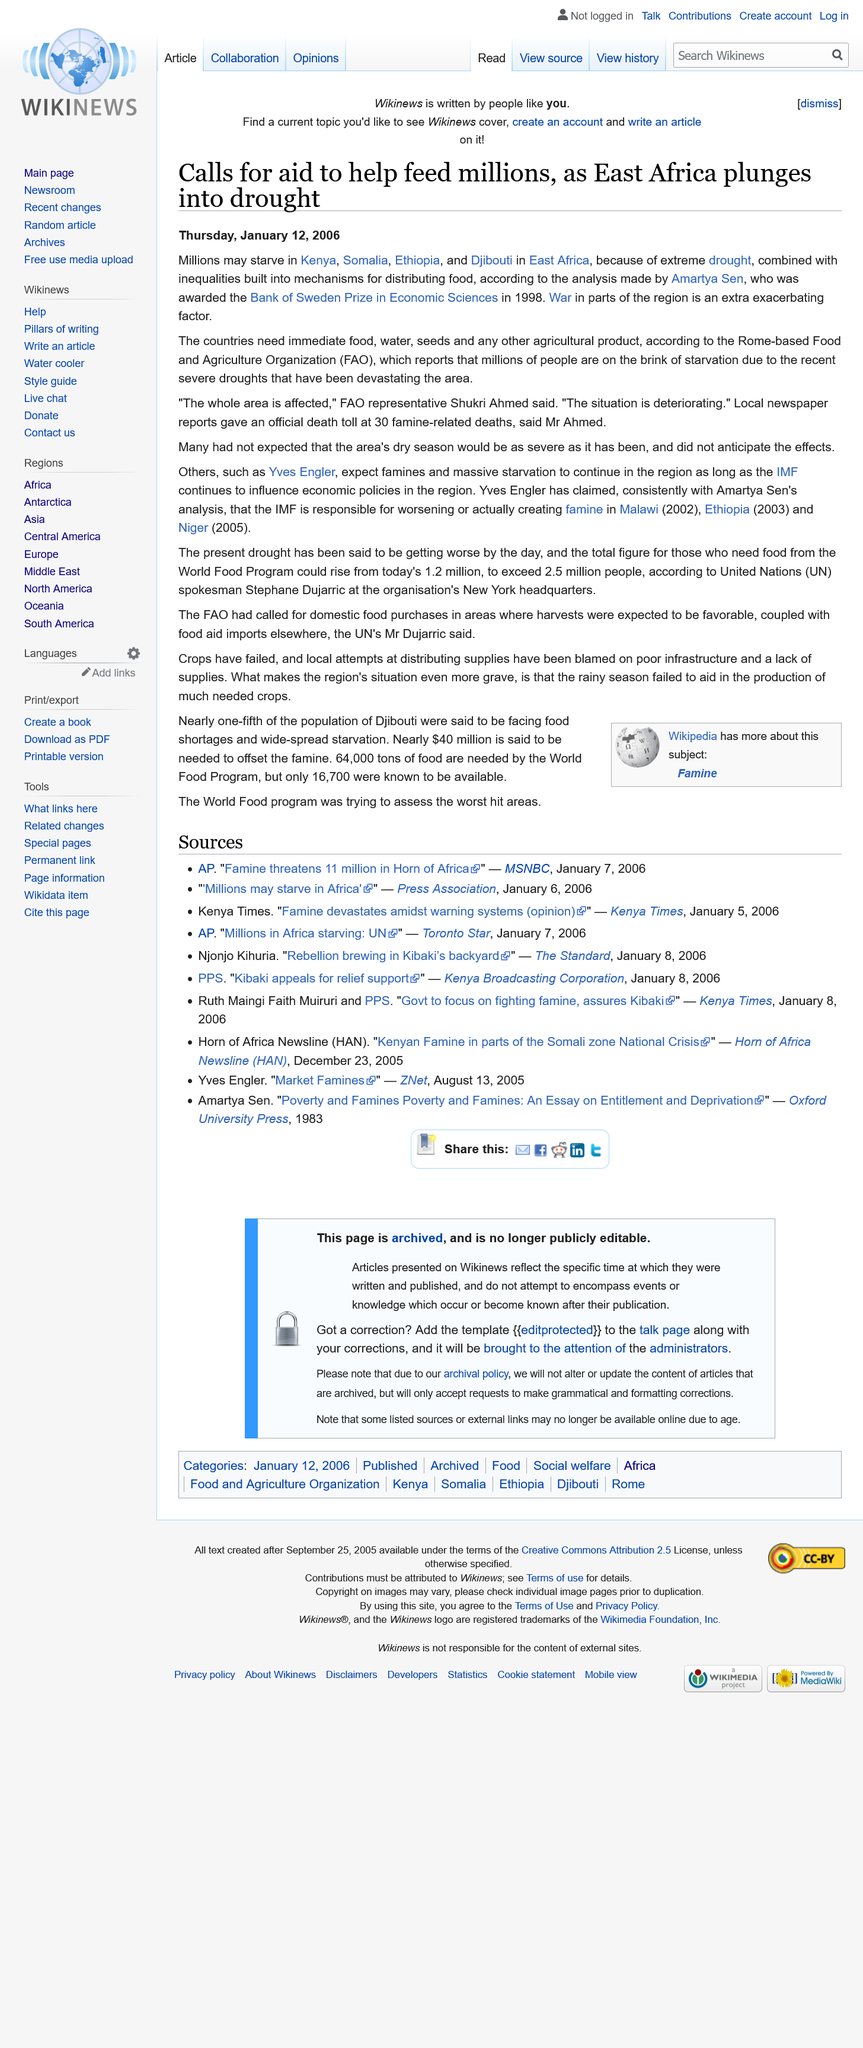Draw attention to some important aspects in this diagram. East Africa, particularly Kenya, Ethiopia, and Somalia, are currently experiencing a severe drought, with dire consequences for the region's inhabitants. There have been 30 official deaths related to famine. The ongoing war in the region is exacerbating the problem and making it worse. 